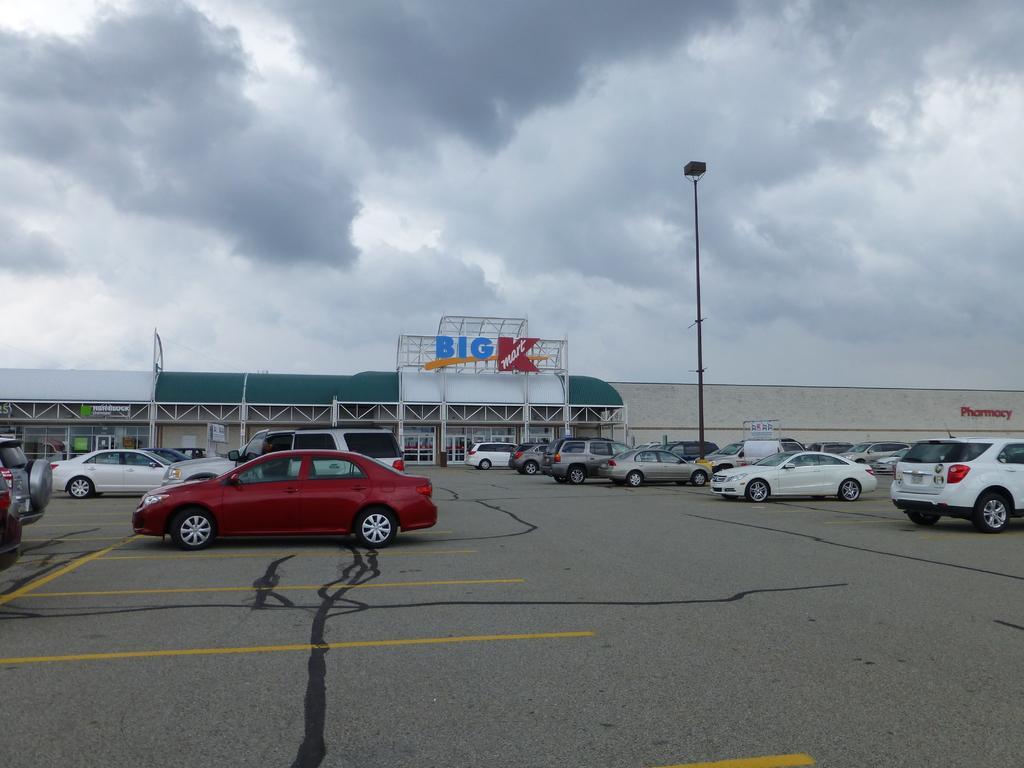Can you describe this image briefly? In this image I can see the ground, few vehicles which are white, black, red and grey in color on the ground, a building which is white and green in color, a black colored poles, a board and the sky in the background 